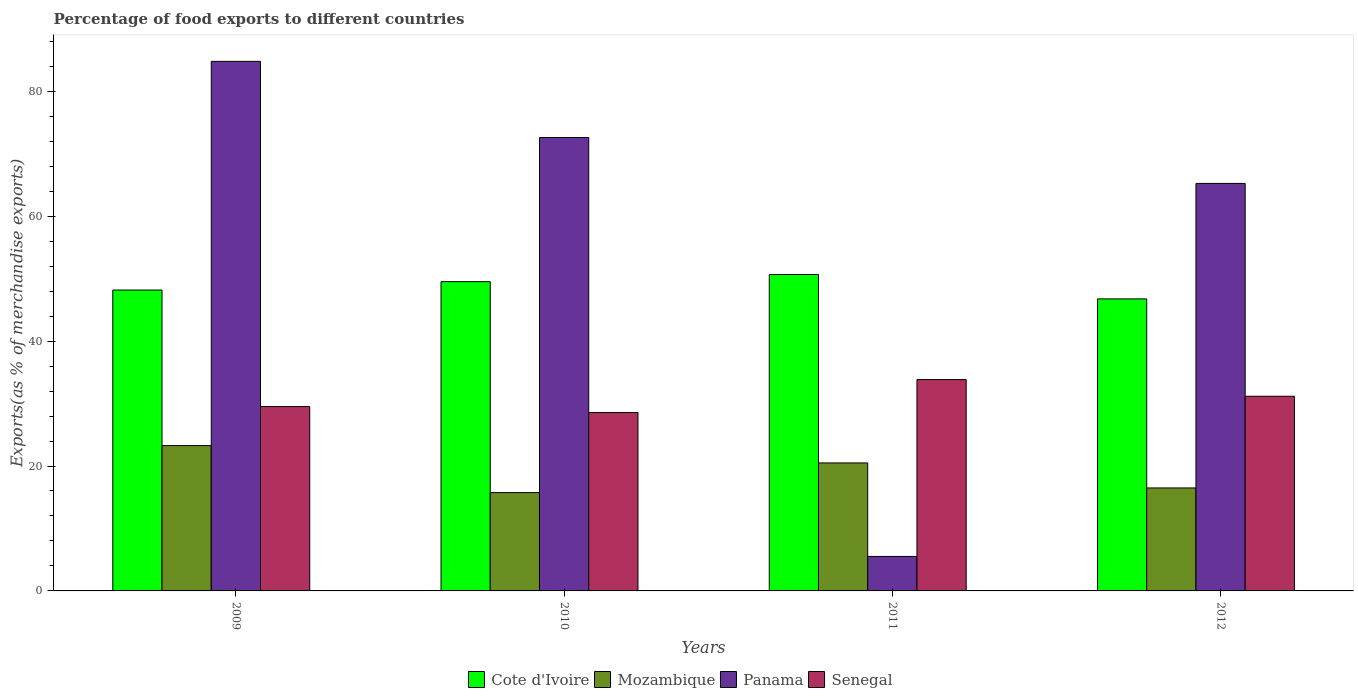How many different coloured bars are there?
Offer a terse response. 4. How many groups of bars are there?
Your answer should be compact. 4. Are the number of bars per tick equal to the number of legend labels?
Keep it short and to the point. Yes. How many bars are there on the 2nd tick from the right?
Ensure brevity in your answer.  4. What is the label of the 2nd group of bars from the left?
Make the answer very short. 2010. In how many cases, is the number of bars for a given year not equal to the number of legend labels?
Your response must be concise. 0. What is the percentage of exports to different countries in Cote d'Ivoire in 2011?
Your answer should be very brief. 50.66. Across all years, what is the maximum percentage of exports to different countries in Panama?
Ensure brevity in your answer.  84.79. Across all years, what is the minimum percentage of exports to different countries in Mozambique?
Offer a very short reply. 15.74. What is the total percentage of exports to different countries in Cote d'Ivoire in the graph?
Keep it short and to the point. 195.1. What is the difference between the percentage of exports to different countries in Panama in 2010 and that in 2011?
Give a very brief answer. 67.07. What is the difference between the percentage of exports to different countries in Mozambique in 2011 and the percentage of exports to different countries in Cote d'Ivoire in 2012?
Provide a succinct answer. -26.26. What is the average percentage of exports to different countries in Cote d'Ivoire per year?
Offer a terse response. 48.78. In the year 2009, what is the difference between the percentage of exports to different countries in Cote d'Ivoire and percentage of exports to different countries in Panama?
Your response must be concise. -36.61. In how many years, is the percentage of exports to different countries in Mozambique greater than 28 %?
Ensure brevity in your answer.  0. What is the ratio of the percentage of exports to different countries in Cote d'Ivoire in 2011 to that in 2012?
Give a very brief answer. 1.08. Is the percentage of exports to different countries in Panama in 2009 less than that in 2012?
Offer a very short reply. No. Is the difference between the percentage of exports to different countries in Cote d'Ivoire in 2010 and 2012 greater than the difference between the percentage of exports to different countries in Panama in 2010 and 2012?
Offer a very short reply. No. What is the difference between the highest and the second highest percentage of exports to different countries in Senegal?
Your answer should be compact. 2.67. What is the difference between the highest and the lowest percentage of exports to different countries in Panama?
Offer a very short reply. 79.27. In how many years, is the percentage of exports to different countries in Panama greater than the average percentage of exports to different countries in Panama taken over all years?
Offer a very short reply. 3. Is the sum of the percentage of exports to different countries in Panama in 2009 and 2011 greater than the maximum percentage of exports to different countries in Mozambique across all years?
Ensure brevity in your answer.  Yes. What does the 3rd bar from the left in 2011 represents?
Provide a succinct answer. Panama. What does the 4th bar from the right in 2012 represents?
Your answer should be very brief. Cote d'Ivoire. Are the values on the major ticks of Y-axis written in scientific E-notation?
Provide a succinct answer. No. How many legend labels are there?
Keep it short and to the point. 4. What is the title of the graph?
Give a very brief answer. Percentage of food exports to different countries. What is the label or title of the X-axis?
Make the answer very short. Years. What is the label or title of the Y-axis?
Give a very brief answer. Exports(as % of merchandise exports). What is the Exports(as % of merchandise exports) in Cote d'Ivoire in 2009?
Offer a very short reply. 48.17. What is the Exports(as % of merchandise exports) of Mozambique in 2009?
Your answer should be very brief. 23.27. What is the Exports(as % of merchandise exports) of Panama in 2009?
Offer a very short reply. 84.79. What is the Exports(as % of merchandise exports) in Senegal in 2009?
Keep it short and to the point. 29.52. What is the Exports(as % of merchandise exports) of Cote d'Ivoire in 2010?
Offer a very short reply. 49.52. What is the Exports(as % of merchandise exports) in Mozambique in 2010?
Provide a short and direct response. 15.74. What is the Exports(as % of merchandise exports) of Panama in 2010?
Keep it short and to the point. 72.59. What is the Exports(as % of merchandise exports) of Senegal in 2010?
Keep it short and to the point. 28.56. What is the Exports(as % of merchandise exports) in Cote d'Ivoire in 2011?
Offer a very short reply. 50.66. What is the Exports(as % of merchandise exports) in Mozambique in 2011?
Ensure brevity in your answer.  20.49. What is the Exports(as % of merchandise exports) of Panama in 2011?
Make the answer very short. 5.52. What is the Exports(as % of merchandise exports) in Senegal in 2011?
Provide a succinct answer. 33.84. What is the Exports(as % of merchandise exports) in Cote d'Ivoire in 2012?
Your answer should be very brief. 46.76. What is the Exports(as % of merchandise exports) in Mozambique in 2012?
Offer a terse response. 16.49. What is the Exports(as % of merchandise exports) in Panama in 2012?
Your answer should be very brief. 65.24. What is the Exports(as % of merchandise exports) in Senegal in 2012?
Keep it short and to the point. 31.17. Across all years, what is the maximum Exports(as % of merchandise exports) of Cote d'Ivoire?
Ensure brevity in your answer.  50.66. Across all years, what is the maximum Exports(as % of merchandise exports) in Mozambique?
Keep it short and to the point. 23.27. Across all years, what is the maximum Exports(as % of merchandise exports) in Panama?
Make the answer very short. 84.79. Across all years, what is the maximum Exports(as % of merchandise exports) in Senegal?
Give a very brief answer. 33.84. Across all years, what is the minimum Exports(as % of merchandise exports) of Cote d'Ivoire?
Keep it short and to the point. 46.76. Across all years, what is the minimum Exports(as % of merchandise exports) of Mozambique?
Give a very brief answer. 15.74. Across all years, what is the minimum Exports(as % of merchandise exports) of Panama?
Make the answer very short. 5.52. Across all years, what is the minimum Exports(as % of merchandise exports) of Senegal?
Provide a short and direct response. 28.56. What is the total Exports(as % of merchandise exports) in Cote d'Ivoire in the graph?
Provide a succinct answer. 195.1. What is the total Exports(as % of merchandise exports) of Mozambique in the graph?
Offer a terse response. 75.99. What is the total Exports(as % of merchandise exports) in Panama in the graph?
Provide a short and direct response. 228.14. What is the total Exports(as % of merchandise exports) of Senegal in the graph?
Your answer should be very brief. 123.08. What is the difference between the Exports(as % of merchandise exports) in Cote d'Ivoire in 2009 and that in 2010?
Keep it short and to the point. -1.34. What is the difference between the Exports(as % of merchandise exports) of Mozambique in 2009 and that in 2010?
Your answer should be very brief. 7.53. What is the difference between the Exports(as % of merchandise exports) of Panama in 2009 and that in 2010?
Make the answer very short. 12.19. What is the difference between the Exports(as % of merchandise exports) in Senegal in 2009 and that in 2010?
Ensure brevity in your answer.  0.96. What is the difference between the Exports(as % of merchandise exports) of Cote d'Ivoire in 2009 and that in 2011?
Offer a terse response. -2.48. What is the difference between the Exports(as % of merchandise exports) of Mozambique in 2009 and that in 2011?
Offer a terse response. 2.78. What is the difference between the Exports(as % of merchandise exports) in Panama in 2009 and that in 2011?
Your answer should be compact. 79.27. What is the difference between the Exports(as % of merchandise exports) of Senegal in 2009 and that in 2011?
Offer a very short reply. -4.32. What is the difference between the Exports(as % of merchandise exports) of Cote d'Ivoire in 2009 and that in 2012?
Provide a succinct answer. 1.42. What is the difference between the Exports(as % of merchandise exports) in Mozambique in 2009 and that in 2012?
Provide a succinct answer. 6.78. What is the difference between the Exports(as % of merchandise exports) of Panama in 2009 and that in 2012?
Keep it short and to the point. 19.54. What is the difference between the Exports(as % of merchandise exports) in Senegal in 2009 and that in 2012?
Your answer should be compact. -1.65. What is the difference between the Exports(as % of merchandise exports) in Cote d'Ivoire in 2010 and that in 2011?
Keep it short and to the point. -1.14. What is the difference between the Exports(as % of merchandise exports) of Mozambique in 2010 and that in 2011?
Provide a succinct answer. -4.75. What is the difference between the Exports(as % of merchandise exports) of Panama in 2010 and that in 2011?
Your answer should be very brief. 67.07. What is the difference between the Exports(as % of merchandise exports) of Senegal in 2010 and that in 2011?
Ensure brevity in your answer.  -5.28. What is the difference between the Exports(as % of merchandise exports) of Cote d'Ivoire in 2010 and that in 2012?
Give a very brief answer. 2.76. What is the difference between the Exports(as % of merchandise exports) in Mozambique in 2010 and that in 2012?
Your answer should be very brief. -0.74. What is the difference between the Exports(as % of merchandise exports) of Panama in 2010 and that in 2012?
Your answer should be compact. 7.35. What is the difference between the Exports(as % of merchandise exports) of Senegal in 2010 and that in 2012?
Ensure brevity in your answer.  -2.61. What is the difference between the Exports(as % of merchandise exports) of Cote d'Ivoire in 2011 and that in 2012?
Offer a terse response. 3.9. What is the difference between the Exports(as % of merchandise exports) of Mozambique in 2011 and that in 2012?
Make the answer very short. 4. What is the difference between the Exports(as % of merchandise exports) in Panama in 2011 and that in 2012?
Your response must be concise. -59.72. What is the difference between the Exports(as % of merchandise exports) in Senegal in 2011 and that in 2012?
Your response must be concise. 2.67. What is the difference between the Exports(as % of merchandise exports) in Cote d'Ivoire in 2009 and the Exports(as % of merchandise exports) in Mozambique in 2010?
Your answer should be compact. 32.43. What is the difference between the Exports(as % of merchandise exports) of Cote d'Ivoire in 2009 and the Exports(as % of merchandise exports) of Panama in 2010?
Your answer should be compact. -24.42. What is the difference between the Exports(as % of merchandise exports) in Cote d'Ivoire in 2009 and the Exports(as % of merchandise exports) in Senegal in 2010?
Provide a short and direct response. 19.61. What is the difference between the Exports(as % of merchandise exports) of Mozambique in 2009 and the Exports(as % of merchandise exports) of Panama in 2010?
Provide a short and direct response. -49.33. What is the difference between the Exports(as % of merchandise exports) of Mozambique in 2009 and the Exports(as % of merchandise exports) of Senegal in 2010?
Your answer should be very brief. -5.29. What is the difference between the Exports(as % of merchandise exports) of Panama in 2009 and the Exports(as % of merchandise exports) of Senegal in 2010?
Your response must be concise. 56.23. What is the difference between the Exports(as % of merchandise exports) of Cote d'Ivoire in 2009 and the Exports(as % of merchandise exports) of Mozambique in 2011?
Give a very brief answer. 27.68. What is the difference between the Exports(as % of merchandise exports) in Cote d'Ivoire in 2009 and the Exports(as % of merchandise exports) in Panama in 2011?
Make the answer very short. 42.65. What is the difference between the Exports(as % of merchandise exports) in Cote d'Ivoire in 2009 and the Exports(as % of merchandise exports) in Senegal in 2011?
Keep it short and to the point. 14.34. What is the difference between the Exports(as % of merchandise exports) of Mozambique in 2009 and the Exports(as % of merchandise exports) of Panama in 2011?
Provide a short and direct response. 17.75. What is the difference between the Exports(as % of merchandise exports) of Mozambique in 2009 and the Exports(as % of merchandise exports) of Senegal in 2011?
Ensure brevity in your answer.  -10.57. What is the difference between the Exports(as % of merchandise exports) of Panama in 2009 and the Exports(as % of merchandise exports) of Senegal in 2011?
Ensure brevity in your answer.  50.95. What is the difference between the Exports(as % of merchandise exports) in Cote d'Ivoire in 2009 and the Exports(as % of merchandise exports) in Mozambique in 2012?
Make the answer very short. 31.69. What is the difference between the Exports(as % of merchandise exports) of Cote d'Ivoire in 2009 and the Exports(as % of merchandise exports) of Panama in 2012?
Make the answer very short. -17.07. What is the difference between the Exports(as % of merchandise exports) of Cote d'Ivoire in 2009 and the Exports(as % of merchandise exports) of Senegal in 2012?
Provide a short and direct response. 17. What is the difference between the Exports(as % of merchandise exports) in Mozambique in 2009 and the Exports(as % of merchandise exports) in Panama in 2012?
Offer a very short reply. -41.98. What is the difference between the Exports(as % of merchandise exports) of Mozambique in 2009 and the Exports(as % of merchandise exports) of Senegal in 2012?
Your answer should be compact. -7.9. What is the difference between the Exports(as % of merchandise exports) of Panama in 2009 and the Exports(as % of merchandise exports) of Senegal in 2012?
Provide a short and direct response. 53.62. What is the difference between the Exports(as % of merchandise exports) of Cote d'Ivoire in 2010 and the Exports(as % of merchandise exports) of Mozambique in 2011?
Your answer should be compact. 29.03. What is the difference between the Exports(as % of merchandise exports) in Cote d'Ivoire in 2010 and the Exports(as % of merchandise exports) in Panama in 2011?
Keep it short and to the point. 44. What is the difference between the Exports(as % of merchandise exports) in Cote d'Ivoire in 2010 and the Exports(as % of merchandise exports) in Senegal in 2011?
Your response must be concise. 15.68. What is the difference between the Exports(as % of merchandise exports) of Mozambique in 2010 and the Exports(as % of merchandise exports) of Panama in 2011?
Your response must be concise. 10.22. What is the difference between the Exports(as % of merchandise exports) in Mozambique in 2010 and the Exports(as % of merchandise exports) in Senegal in 2011?
Make the answer very short. -18.09. What is the difference between the Exports(as % of merchandise exports) of Panama in 2010 and the Exports(as % of merchandise exports) of Senegal in 2011?
Offer a terse response. 38.76. What is the difference between the Exports(as % of merchandise exports) in Cote d'Ivoire in 2010 and the Exports(as % of merchandise exports) in Mozambique in 2012?
Offer a terse response. 33.03. What is the difference between the Exports(as % of merchandise exports) in Cote d'Ivoire in 2010 and the Exports(as % of merchandise exports) in Panama in 2012?
Your response must be concise. -15.73. What is the difference between the Exports(as % of merchandise exports) in Cote d'Ivoire in 2010 and the Exports(as % of merchandise exports) in Senegal in 2012?
Provide a succinct answer. 18.35. What is the difference between the Exports(as % of merchandise exports) of Mozambique in 2010 and the Exports(as % of merchandise exports) of Panama in 2012?
Keep it short and to the point. -49.5. What is the difference between the Exports(as % of merchandise exports) in Mozambique in 2010 and the Exports(as % of merchandise exports) in Senegal in 2012?
Offer a terse response. -15.43. What is the difference between the Exports(as % of merchandise exports) in Panama in 2010 and the Exports(as % of merchandise exports) in Senegal in 2012?
Make the answer very short. 41.43. What is the difference between the Exports(as % of merchandise exports) in Cote d'Ivoire in 2011 and the Exports(as % of merchandise exports) in Mozambique in 2012?
Your answer should be very brief. 34.17. What is the difference between the Exports(as % of merchandise exports) in Cote d'Ivoire in 2011 and the Exports(as % of merchandise exports) in Panama in 2012?
Make the answer very short. -14.59. What is the difference between the Exports(as % of merchandise exports) of Cote d'Ivoire in 2011 and the Exports(as % of merchandise exports) of Senegal in 2012?
Your answer should be compact. 19.49. What is the difference between the Exports(as % of merchandise exports) of Mozambique in 2011 and the Exports(as % of merchandise exports) of Panama in 2012?
Keep it short and to the point. -44.75. What is the difference between the Exports(as % of merchandise exports) in Mozambique in 2011 and the Exports(as % of merchandise exports) in Senegal in 2012?
Your answer should be very brief. -10.68. What is the difference between the Exports(as % of merchandise exports) in Panama in 2011 and the Exports(as % of merchandise exports) in Senegal in 2012?
Make the answer very short. -25.65. What is the average Exports(as % of merchandise exports) in Cote d'Ivoire per year?
Offer a terse response. 48.78. What is the average Exports(as % of merchandise exports) of Mozambique per year?
Your answer should be very brief. 19. What is the average Exports(as % of merchandise exports) in Panama per year?
Provide a short and direct response. 57.04. What is the average Exports(as % of merchandise exports) in Senegal per year?
Your answer should be very brief. 30.77. In the year 2009, what is the difference between the Exports(as % of merchandise exports) of Cote d'Ivoire and Exports(as % of merchandise exports) of Mozambique?
Your answer should be very brief. 24.91. In the year 2009, what is the difference between the Exports(as % of merchandise exports) of Cote d'Ivoire and Exports(as % of merchandise exports) of Panama?
Give a very brief answer. -36.61. In the year 2009, what is the difference between the Exports(as % of merchandise exports) of Cote d'Ivoire and Exports(as % of merchandise exports) of Senegal?
Provide a short and direct response. 18.65. In the year 2009, what is the difference between the Exports(as % of merchandise exports) in Mozambique and Exports(as % of merchandise exports) in Panama?
Offer a terse response. -61.52. In the year 2009, what is the difference between the Exports(as % of merchandise exports) of Mozambique and Exports(as % of merchandise exports) of Senegal?
Keep it short and to the point. -6.25. In the year 2009, what is the difference between the Exports(as % of merchandise exports) in Panama and Exports(as % of merchandise exports) in Senegal?
Provide a short and direct response. 55.27. In the year 2010, what is the difference between the Exports(as % of merchandise exports) in Cote d'Ivoire and Exports(as % of merchandise exports) in Mozambique?
Ensure brevity in your answer.  33.78. In the year 2010, what is the difference between the Exports(as % of merchandise exports) of Cote d'Ivoire and Exports(as % of merchandise exports) of Panama?
Your answer should be very brief. -23.08. In the year 2010, what is the difference between the Exports(as % of merchandise exports) in Cote d'Ivoire and Exports(as % of merchandise exports) in Senegal?
Keep it short and to the point. 20.96. In the year 2010, what is the difference between the Exports(as % of merchandise exports) of Mozambique and Exports(as % of merchandise exports) of Panama?
Keep it short and to the point. -56.85. In the year 2010, what is the difference between the Exports(as % of merchandise exports) in Mozambique and Exports(as % of merchandise exports) in Senegal?
Make the answer very short. -12.82. In the year 2010, what is the difference between the Exports(as % of merchandise exports) in Panama and Exports(as % of merchandise exports) in Senegal?
Your answer should be compact. 44.03. In the year 2011, what is the difference between the Exports(as % of merchandise exports) of Cote d'Ivoire and Exports(as % of merchandise exports) of Mozambique?
Offer a very short reply. 30.17. In the year 2011, what is the difference between the Exports(as % of merchandise exports) in Cote d'Ivoire and Exports(as % of merchandise exports) in Panama?
Your answer should be very brief. 45.14. In the year 2011, what is the difference between the Exports(as % of merchandise exports) of Cote d'Ivoire and Exports(as % of merchandise exports) of Senegal?
Your response must be concise. 16.82. In the year 2011, what is the difference between the Exports(as % of merchandise exports) in Mozambique and Exports(as % of merchandise exports) in Panama?
Make the answer very short. 14.97. In the year 2011, what is the difference between the Exports(as % of merchandise exports) of Mozambique and Exports(as % of merchandise exports) of Senegal?
Offer a terse response. -13.35. In the year 2011, what is the difference between the Exports(as % of merchandise exports) of Panama and Exports(as % of merchandise exports) of Senegal?
Offer a terse response. -28.32. In the year 2012, what is the difference between the Exports(as % of merchandise exports) in Cote d'Ivoire and Exports(as % of merchandise exports) in Mozambique?
Offer a very short reply. 30.27. In the year 2012, what is the difference between the Exports(as % of merchandise exports) of Cote d'Ivoire and Exports(as % of merchandise exports) of Panama?
Your answer should be compact. -18.49. In the year 2012, what is the difference between the Exports(as % of merchandise exports) of Cote d'Ivoire and Exports(as % of merchandise exports) of Senegal?
Ensure brevity in your answer.  15.59. In the year 2012, what is the difference between the Exports(as % of merchandise exports) in Mozambique and Exports(as % of merchandise exports) in Panama?
Your answer should be very brief. -48.76. In the year 2012, what is the difference between the Exports(as % of merchandise exports) in Mozambique and Exports(as % of merchandise exports) in Senegal?
Your answer should be compact. -14.68. In the year 2012, what is the difference between the Exports(as % of merchandise exports) in Panama and Exports(as % of merchandise exports) in Senegal?
Your answer should be very brief. 34.08. What is the ratio of the Exports(as % of merchandise exports) of Cote d'Ivoire in 2009 to that in 2010?
Your answer should be very brief. 0.97. What is the ratio of the Exports(as % of merchandise exports) of Mozambique in 2009 to that in 2010?
Offer a terse response. 1.48. What is the ratio of the Exports(as % of merchandise exports) of Panama in 2009 to that in 2010?
Ensure brevity in your answer.  1.17. What is the ratio of the Exports(as % of merchandise exports) of Senegal in 2009 to that in 2010?
Your response must be concise. 1.03. What is the ratio of the Exports(as % of merchandise exports) in Cote d'Ivoire in 2009 to that in 2011?
Give a very brief answer. 0.95. What is the ratio of the Exports(as % of merchandise exports) of Mozambique in 2009 to that in 2011?
Offer a terse response. 1.14. What is the ratio of the Exports(as % of merchandise exports) of Panama in 2009 to that in 2011?
Ensure brevity in your answer.  15.36. What is the ratio of the Exports(as % of merchandise exports) of Senegal in 2009 to that in 2011?
Your response must be concise. 0.87. What is the ratio of the Exports(as % of merchandise exports) of Cote d'Ivoire in 2009 to that in 2012?
Provide a succinct answer. 1.03. What is the ratio of the Exports(as % of merchandise exports) of Mozambique in 2009 to that in 2012?
Provide a succinct answer. 1.41. What is the ratio of the Exports(as % of merchandise exports) of Panama in 2009 to that in 2012?
Your answer should be very brief. 1.3. What is the ratio of the Exports(as % of merchandise exports) in Senegal in 2009 to that in 2012?
Give a very brief answer. 0.95. What is the ratio of the Exports(as % of merchandise exports) in Cote d'Ivoire in 2010 to that in 2011?
Make the answer very short. 0.98. What is the ratio of the Exports(as % of merchandise exports) in Mozambique in 2010 to that in 2011?
Your answer should be very brief. 0.77. What is the ratio of the Exports(as % of merchandise exports) of Panama in 2010 to that in 2011?
Provide a short and direct response. 13.15. What is the ratio of the Exports(as % of merchandise exports) in Senegal in 2010 to that in 2011?
Ensure brevity in your answer.  0.84. What is the ratio of the Exports(as % of merchandise exports) of Cote d'Ivoire in 2010 to that in 2012?
Keep it short and to the point. 1.06. What is the ratio of the Exports(as % of merchandise exports) in Mozambique in 2010 to that in 2012?
Give a very brief answer. 0.95. What is the ratio of the Exports(as % of merchandise exports) of Panama in 2010 to that in 2012?
Provide a succinct answer. 1.11. What is the ratio of the Exports(as % of merchandise exports) of Senegal in 2010 to that in 2012?
Ensure brevity in your answer.  0.92. What is the ratio of the Exports(as % of merchandise exports) in Cote d'Ivoire in 2011 to that in 2012?
Your answer should be very brief. 1.08. What is the ratio of the Exports(as % of merchandise exports) of Mozambique in 2011 to that in 2012?
Offer a terse response. 1.24. What is the ratio of the Exports(as % of merchandise exports) in Panama in 2011 to that in 2012?
Your answer should be very brief. 0.08. What is the ratio of the Exports(as % of merchandise exports) in Senegal in 2011 to that in 2012?
Keep it short and to the point. 1.09. What is the difference between the highest and the second highest Exports(as % of merchandise exports) in Cote d'Ivoire?
Ensure brevity in your answer.  1.14. What is the difference between the highest and the second highest Exports(as % of merchandise exports) of Mozambique?
Provide a succinct answer. 2.78. What is the difference between the highest and the second highest Exports(as % of merchandise exports) in Panama?
Offer a very short reply. 12.19. What is the difference between the highest and the second highest Exports(as % of merchandise exports) of Senegal?
Ensure brevity in your answer.  2.67. What is the difference between the highest and the lowest Exports(as % of merchandise exports) of Cote d'Ivoire?
Provide a short and direct response. 3.9. What is the difference between the highest and the lowest Exports(as % of merchandise exports) in Mozambique?
Your response must be concise. 7.53. What is the difference between the highest and the lowest Exports(as % of merchandise exports) in Panama?
Your answer should be very brief. 79.27. What is the difference between the highest and the lowest Exports(as % of merchandise exports) of Senegal?
Your response must be concise. 5.28. 